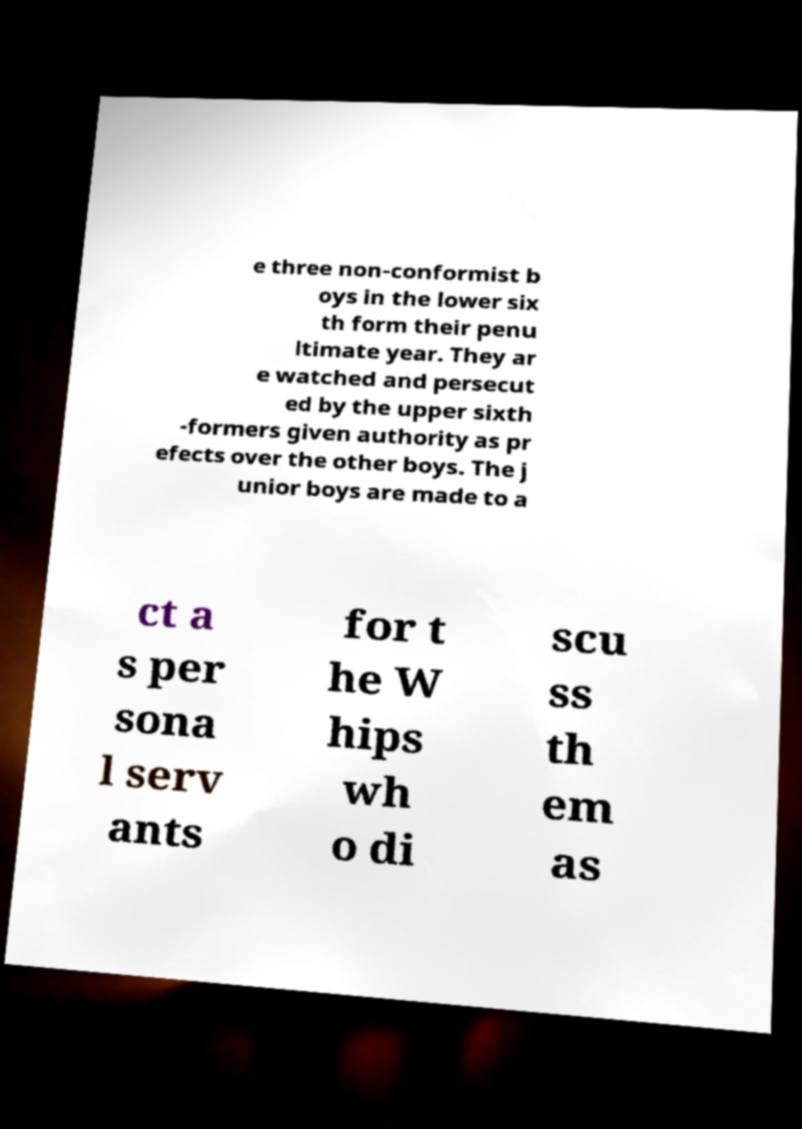What messages or text are displayed in this image? I need them in a readable, typed format. e three non-conformist b oys in the lower six th form their penu ltimate year. They ar e watched and persecut ed by the upper sixth -formers given authority as pr efects over the other boys. The j unior boys are made to a ct a s per sona l serv ants for t he W hips wh o di scu ss th em as 